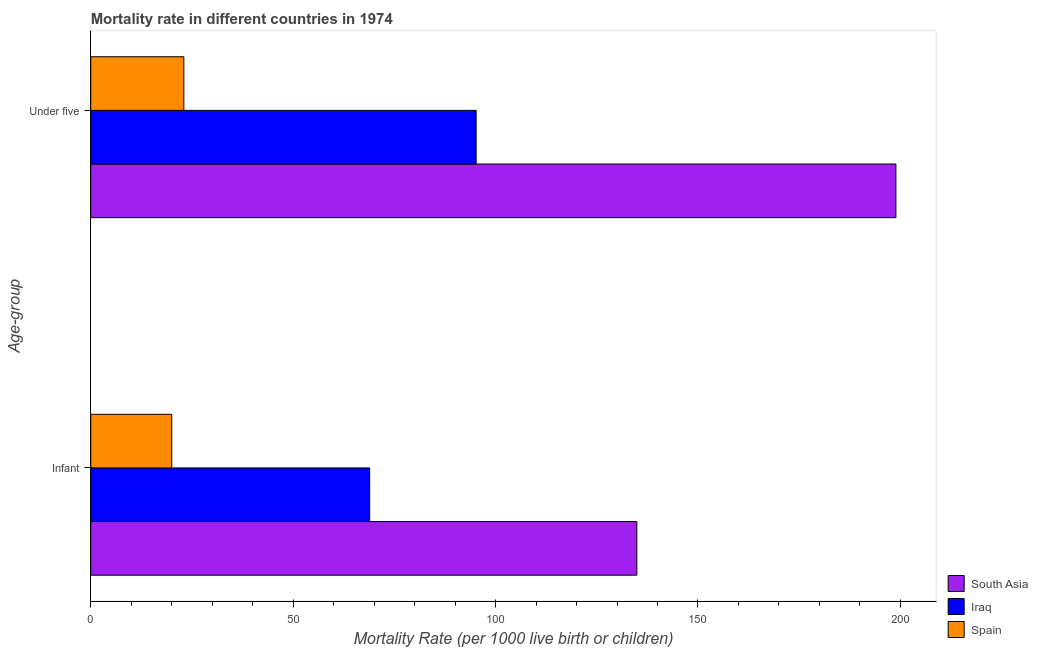How many different coloured bars are there?
Give a very brief answer. 3. How many groups of bars are there?
Your response must be concise. 2. What is the label of the 1st group of bars from the top?
Make the answer very short. Under five. What is the infant mortality rate in South Asia?
Provide a succinct answer. 134.9. Across all countries, what is the maximum infant mortality rate?
Give a very brief answer. 134.9. In which country was the infant mortality rate maximum?
Your answer should be very brief. South Asia. What is the total under-5 mortality rate in the graph?
Your answer should be very brief. 317.1. What is the difference between the under-5 mortality rate in Iraq and that in Spain?
Offer a terse response. 72.2. What is the difference between the infant mortality rate in South Asia and the under-5 mortality rate in Iraq?
Offer a very short reply. 39.7. What is the average infant mortality rate per country?
Your answer should be very brief. 74.6. What is the difference between the infant mortality rate and under-5 mortality rate in Spain?
Ensure brevity in your answer.  -3. In how many countries, is the under-5 mortality rate greater than 110 ?
Provide a short and direct response. 1. What is the ratio of the infant mortality rate in Iraq to that in Spain?
Make the answer very short. 3.45. In how many countries, is the under-5 mortality rate greater than the average under-5 mortality rate taken over all countries?
Provide a short and direct response. 1. What does the 1st bar from the bottom in Infant represents?
Keep it short and to the point. South Asia. How many bars are there?
Your answer should be very brief. 6. What is the difference between two consecutive major ticks on the X-axis?
Make the answer very short. 50. Where does the legend appear in the graph?
Your response must be concise. Bottom right. How many legend labels are there?
Your answer should be very brief. 3. What is the title of the graph?
Ensure brevity in your answer.  Mortality rate in different countries in 1974. What is the label or title of the X-axis?
Provide a short and direct response. Mortality Rate (per 1000 live birth or children). What is the label or title of the Y-axis?
Your response must be concise. Age-group. What is the Mortality Rate (per 1000 live birth or children) of South Asia in Infant?
Make the answer very short. 134.9. What is the Mortality Rate (per 1000 live birth or children) of Iraq in Infant?
Offer a terse response. 68.9. What is the Mortality Rate (per 1000 live birth or children) of South Asia in Under five?
Ensure brevity in your answer.  198.9. What is the Mortality Rate (per 1000 live birth or children) in Iraq in Under five?
Your answer should be very brief. 95.2. Across all Age-group, what is the maximum Mortality Rate (per 1000 live birth or children) in South Asia?
Provide a succinct answer. 198.9. Across all Age-group, what is the maximum Mortality Rate (per 1000 live birth or children) of Iraq?
Ensure brevity in your answer.  95.2. Across all Age-group, what is the minimum Mortality Rate (per 1000 live birth or children) in South Asia?
Offer a very short reply. 134.9. Across all Age-group, what is the minimum Mortality Rate (per 1000 live birth or children) of Iraq?
Your answer should be very brief. 68.9. Across all Age-group, what is the minimum Mortality Rate (per 1000 live birth or children) in Spain?
Ensure brevity in your answer.  20. What is the total Mortality Rate (per 1000 live birth or children) of South Asia in the graph?
Give a very brief answer. 333.8. What is the total Mortality Rate (per 1000 live birth or children) of Iraq in the graph?
Give a very brief answer. 164.1. What is the total Mortality Rate (per 1000 live birth or children) of Spain in the graph?
Your response must be concise. 43. What is the difference between the Mortality Rate (per 1000 live birth or children) of South Asia in Infant and that in Under five?
Give a very brief answer. -64. What is the difference between the Mortality Rate (per 1000 live birth or children) of Iraq in Infant and that in Under five?
Your answer should be very brief. -26.3. What is the difference between the Mortality Rate (per 1000 live birth or children) of Spain in Infant and that in Under five?
Your response must be concise. -3. What is the difference between the Mortality Rate (per 1000 live birth or children) of South Asia in Infant and the Mortality Rate (per 1000 live birth or children) of Iraq in Under five?
Make the answer very short. 39.7. What is the difference between the Mortality Rate (per 1000 live birth or children) in South Asia in Infant and the Mortality Rate (per 1000 live birth or children) in Spain in Under five?
Ensure brevity in your answer.  111.9. What is the difference between the Mortality Rate (per 1000 live birth or children) in Iraq in Infant and the Mortality Rate (per 1000 live birth or children) in Spain in Under five?
Offer a terse response. 45.9. What is the average Mortality Rate (per 1000 live birth or children) in South Asia per Age-group?
Offer a terse response. 166.9. What is the average Mortality Rate (per 1000 live birth or children) of Iraq per Age-group?
Provide a succinct answer. 82.05. What is the average Mortality Rate (per 1000 live birth or children) of Spain per Age-group?
Offer a terse response. 21.5. What is the difference between the Mortality Rate (per 1000 live birth or children) of South Asia and Mortality Rate (per 1000 live birth or children) of Spain in Infant?
Make the answer very short. 114.9. What is the difference between the Mortality Rate (per 1000 live birth or children) of Iraq and Mortality Rate (per 1000 live birth or children) of Spain in Infant?
Provide a short and direct response. 48.9. What is the difference between the Mortality Rate (per 1000 live birth or children) of South Asia and Mortality Rate (per 1000 live birth or children) of Iraq in Under five?
Your answer should be compact. 103.7. What is the difference between the Mortality Rate (per 1000 live birth or children) of South Asia and Mortality Rate (per 1000 live birth or children) of Spain in Under five?
Give a very brief answer. 175.9. What is the difference between the Mortality Rate (per 1000 live birth or children) in Iraq and Mortality Rate (per 1000 live birth or children) in Spain in Under five?
Offer a terse response. 72.2. What is the ratio of the Mortality Rate (per 1000 live birth or children) of South Asia in Infant to that in Under five?
Offer a terse response. 0.68. What is the ratio of the Mortality Rate (per 1000 live birth or children) of Iraq in Infant to that in Under five?
Your answer should be compact. 0.72. What is the ratio of the Mortality Rate (per 1000 live birth or children) in Spain in Infant to that in Under five?
Keep it short and to the point. 0.87. What is the difference between the highest and the second highest Mortality Rate (per 1000 live birth or children) of South Asia?
Offer a very short reply. 64. What is the difference between the highest and the second highest Mortality Rate (per 1000 live birth or children) of Iraq?
Offer a very short reply. 26.3. What is the difference between the highest and the lowest Mortality Rate (per 1000 live birth or children) of Iraq?
Offer a very short reply. 26.3. What is the difference between the highest and the lowest Mortality Rate (per 1000 live birth or children) in Spain?
Offer a very short reply. 3. 